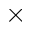<formula> <loc_0><loc_0><loc_500><loc_500>\times</formula> 